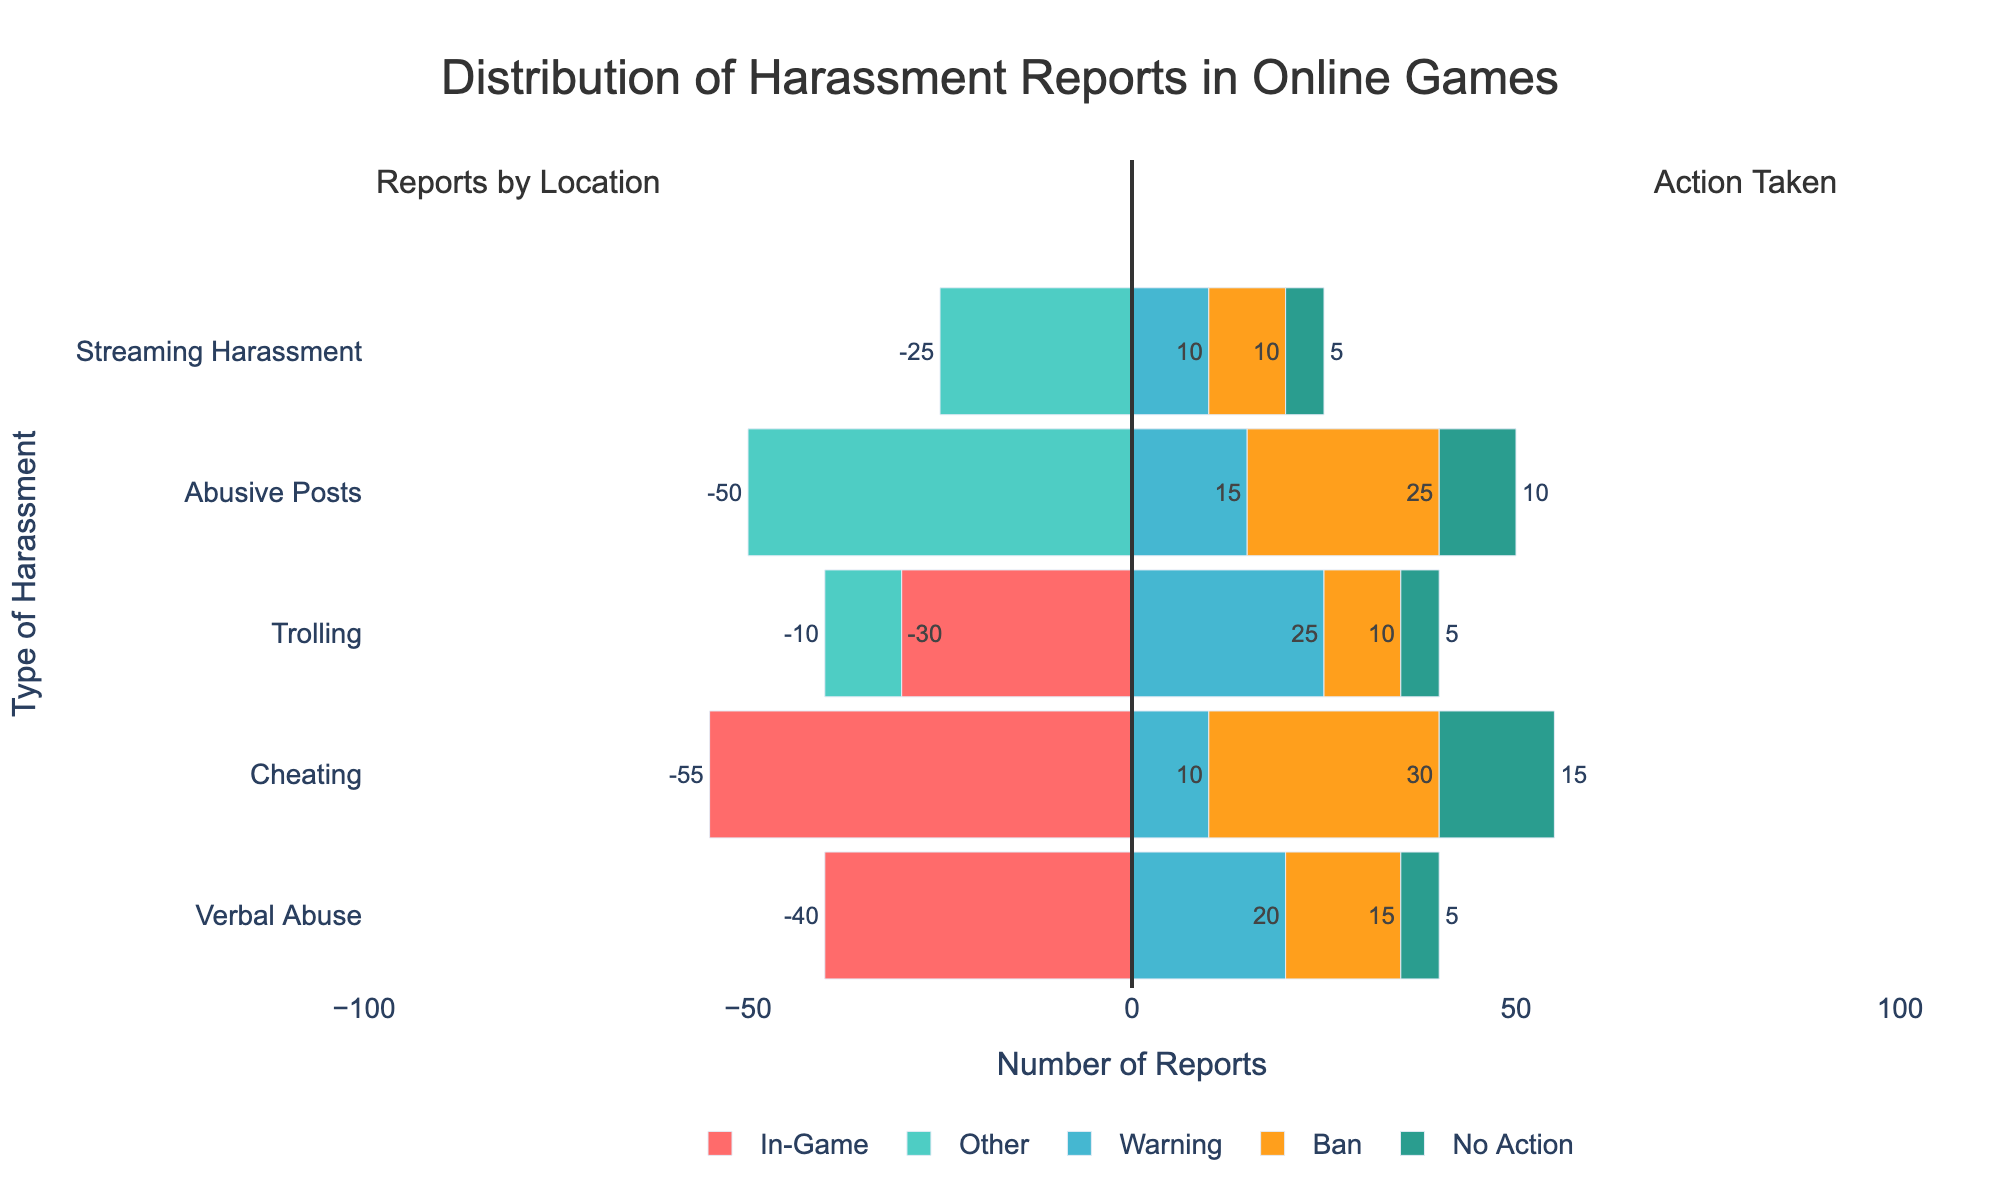What type of harassment has the highest total number of reports? Add up all categories for each type of harassment and compare the totals. Verbal Abuse has (35 verbal + 5 trolling = 40), Cheating has (55 in-game = 55), Trolling has (5 verbal + 5 cheating + 20 trolling + 10 forum = 40), Abusive Posts has (50 forum = 50), Streaming Harassment has (25 streaming = 25). Cheating has the highest total number of reports.
Answer: Cheating Which type of harassment receives the most "ban" actions? Compare the length of the "ban" bars for each type of harassment. Cheating's ban bar is the longest, indicating it has the most bans.
Answer: Cheating How many more "in-game" reports are there for Verbal Abuse compared to Trolling? Subtract the total in-game reports for Trolling from those for Verbal Abuse. For Verbal Abuse, in-game reports are 35. For Trolling, in-game reports are (5 verbal + 5 cheating + 20 trolling = 30). So, 35 - 30 = 5 more in-game reports.
Answer: 5 Which type of harassment has the most "no action" taken? Compare the length of the "no action" bars for each type of harassment. Cheating has the longest "no action" bar.
Answer: Cheating What is the ratio of "warning" to "ban" actions for Trolling? Divide the number of "warning" actions by the number of "ban" actions for Trolling. Trolling has 25 warnings and 10 bans. So, 25 / 10 = 2.5.
Answer: 2.5 Which type of harassment has the smallest combined total for "warning" and "ban" actions? Add the warning and ban actions for each harassment type, then compare the sums. Streaming Harassment has (10 warning + 10 ban = 20), the smallest combined total.
Answer: Streaming Harassment Does Abusive Posts receive more warnings or bans? Compare the length of the "warning" and "ban" bars for Abusive Posts. The "ban" bar is longer, indicating more bans.
Answer: Bans 